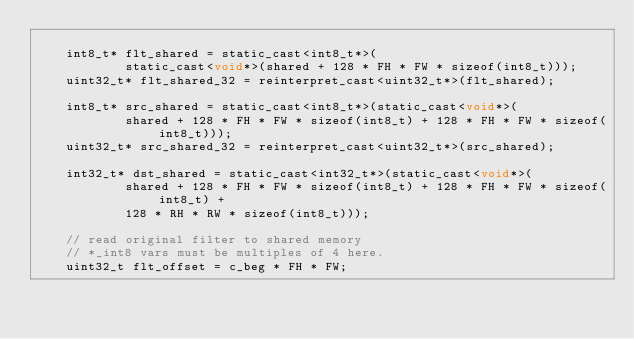<code> <loc_0><loc_0><loc_500><loc_500><_Cuda_>
    int8_t* flt_shared = static_cast<int8_t*>(
            static_cast<void*>(shared + 128 * FH * FW * sizeof(int8_t)));
    uint32_t* flt_shared_32 = reinterpret_cast<uint32_t*>(flt_shared);

    int8_t* src_shared = static_cast<int8_t*>(static_cast<void*>(
            shared + 128 * FH * FW * sizeof(int8_t) + 128 * FH * FW * sizeof(int8_t)));
    uint32_t* src_shared_32 = reinterpret_cast<uint32_t*>(src_shared);

    int32_t* dst_shared = static_cast<int32_t*>(static_cast<void*>(
            shared + 128 * FH * FW * sizeof(int8_t) + 128 * FH * FW * sizeof(int8_t) +
            128 * RH * RW * sizeof(int8_t)));

    // read original filter to shared memory
    // *_int8 vars must be multiples of 4 here.
    uint32_t flt_offset = c_beg * FH * FW;</code> 